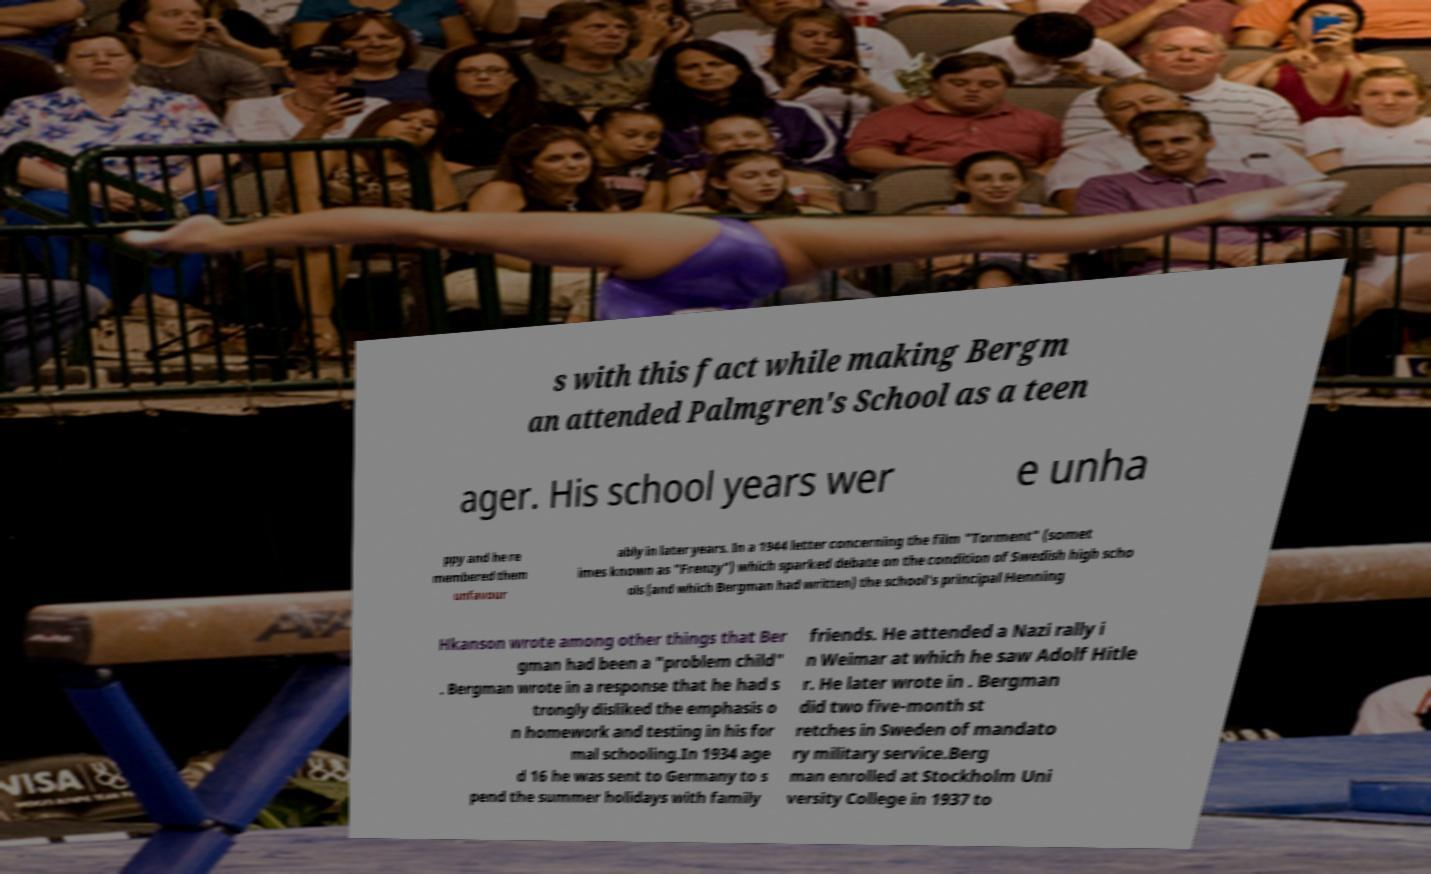Please identify and transcribe the text found in this image. s with this fact while making Bergm an attended Palmgren's School as a teen ager. His school years wer e unha ppy and he re membered them unfavour ably in later years. In a 1944 letter concerning the film "Torment" (somet imes known as "Frenzy") which sparked debate on the condition of Swedish high scho ols (and which Bergman had written) the school's principal Henning Hkanson wrote among other things that Ber gman had been a "problem child" . Bergman wrote in a response that he had s trongly disliked the emphasis o n homework and testing in his for mal schooling.In 1934 age d 16 he was sent to Germany to s pend the summer holidays with family friends. He attended a Nazi rally i n Weimar at which he saw Adolf Hitle r. He later wrote in . Bergman did two five-month st retches in Sweden of mandato ry military service.Berg man enrolled at Stockholm Uni versity College in 1937 to 